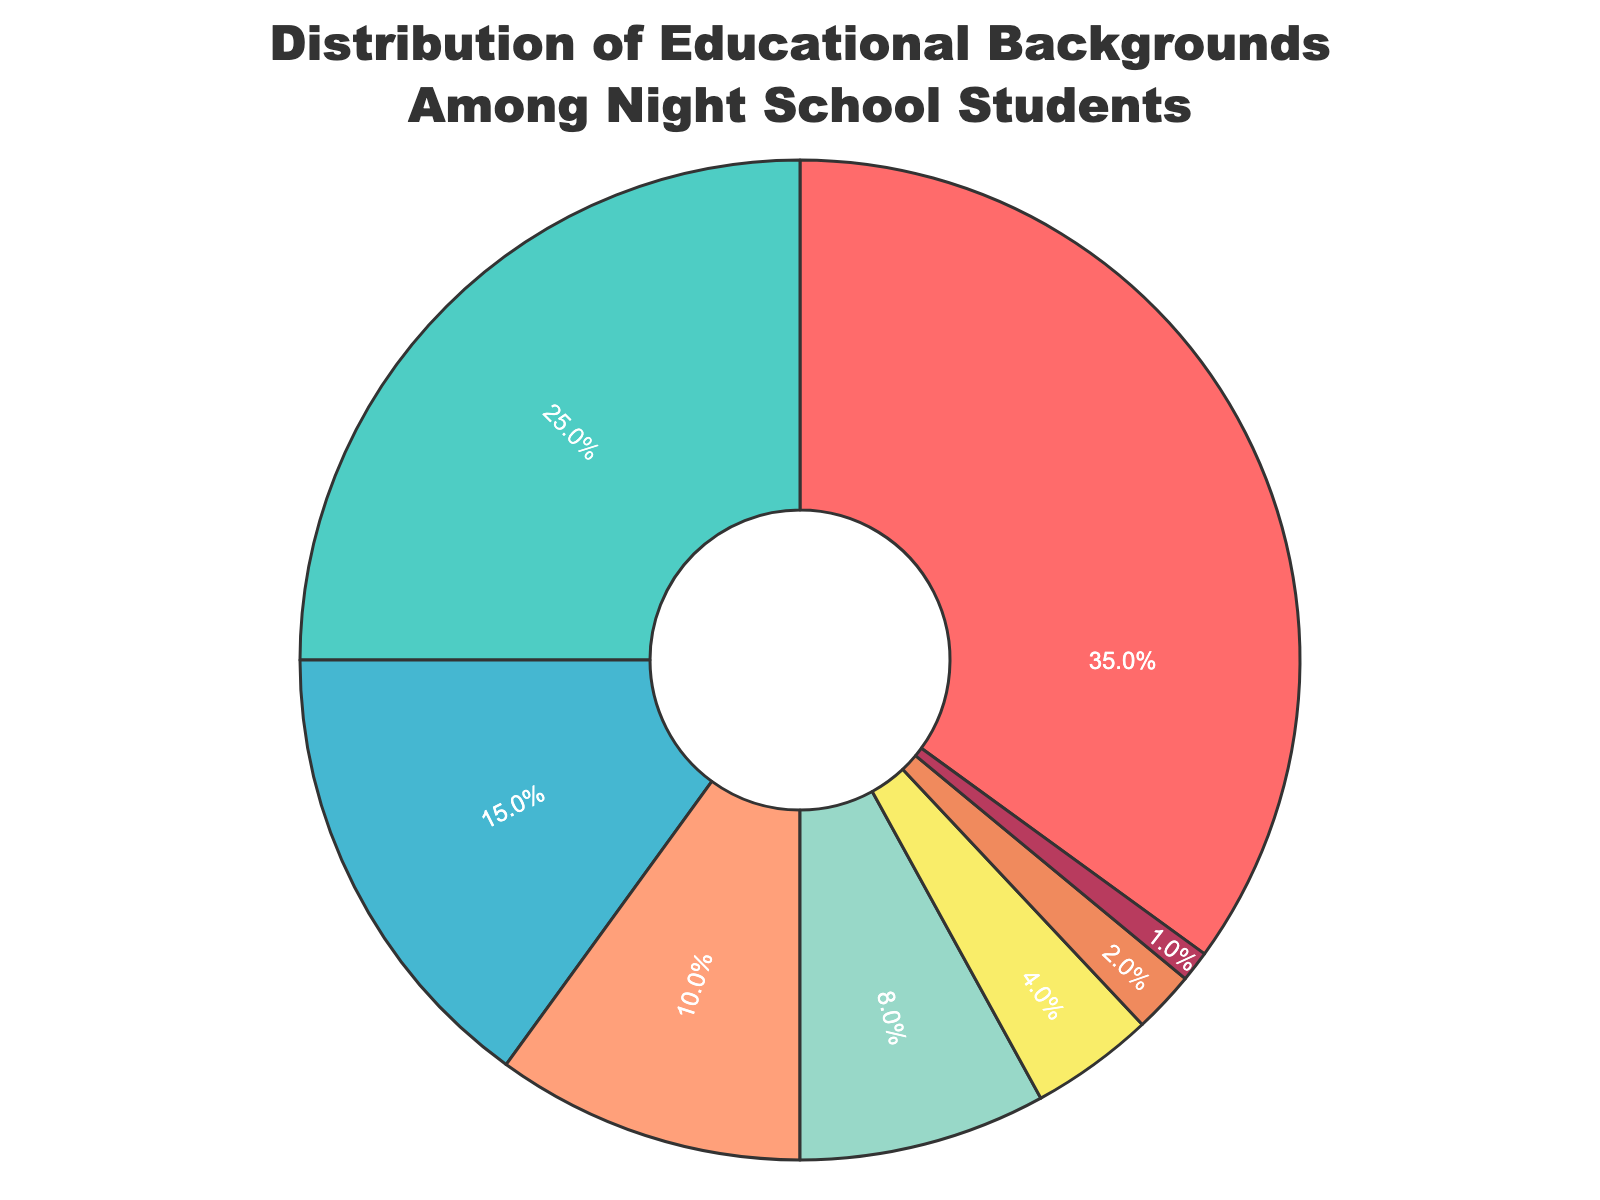Which educational background has the highest percentage among night school students? Looking at the pie chart, the largest section is labeled "High School Diploma," occupying 35% of the chart.
Answer: High School Diploma Which two educational backgrounds together make up 40% of the night school students? The chart shows that "Some College" is 25% and "GED" is 15%. Adding these two values together gives 25% + 15% = 40%.
Answer: Some College and GED How does the percentage of students with a Bachelor's Degree compare to those with an Associate's Degree? The chart shows that "Bachelor's Degree" has 8% and "Associate's Degree" has 10%. Therefore, the Bachelor's Degree percentage is less than the Associate's Degree percentage.
Answer: Bachelor's Degree has less percentage What is the combined percentage of students with no formal education and those with a trade school certificate? The chart shows "No Formal Education" at 4% and "Trade School Certificate" at 2%. Adding these together gives 4% + 2% = 6%.
Answer: 6% Which section of the pie chart is visually the smallest? The smallest section of the pie chart is labeled "Master's Degree," occupying 1% of the chart.
Answer: Master's Degree If the school has 1,000 students, how many have a Bachelor's Degree? To find the number of students with a Bachelor's Degree, multiply the total number of students by the percentage for Bachelor's Degree: 1000 * 8% = 80 students.
Answer: 80 How does the segment color for "High School Diploma" compare to that for "Master's Degree"? The "High School Diploma" segment is red, while the "Master's Degree" segment is purple.
Answer: Red and purple What percentage of students have at least an Associate's Degree? Adding the percentages of "Associate's Degree" (10%), "Bachelor's Degree" (8%), and "Master's Degree" (1%) gives a total of 10% + 8% + 1% = 19%.
Answer: 19% What percentage of students have less than a high school diploma? Adding the percentages of "No Formal Education" (4%) and "GED" (15%) gives a total of 4% + 15% = 19%.
Answer: 19% Which segment is larger: "Some College" or "Associate's Degree"? The chart shows "Some College" at 25% and "Associate's Degree" at 10%. Therefore, the segment for "Some College" is larger.
Answer: Some College 